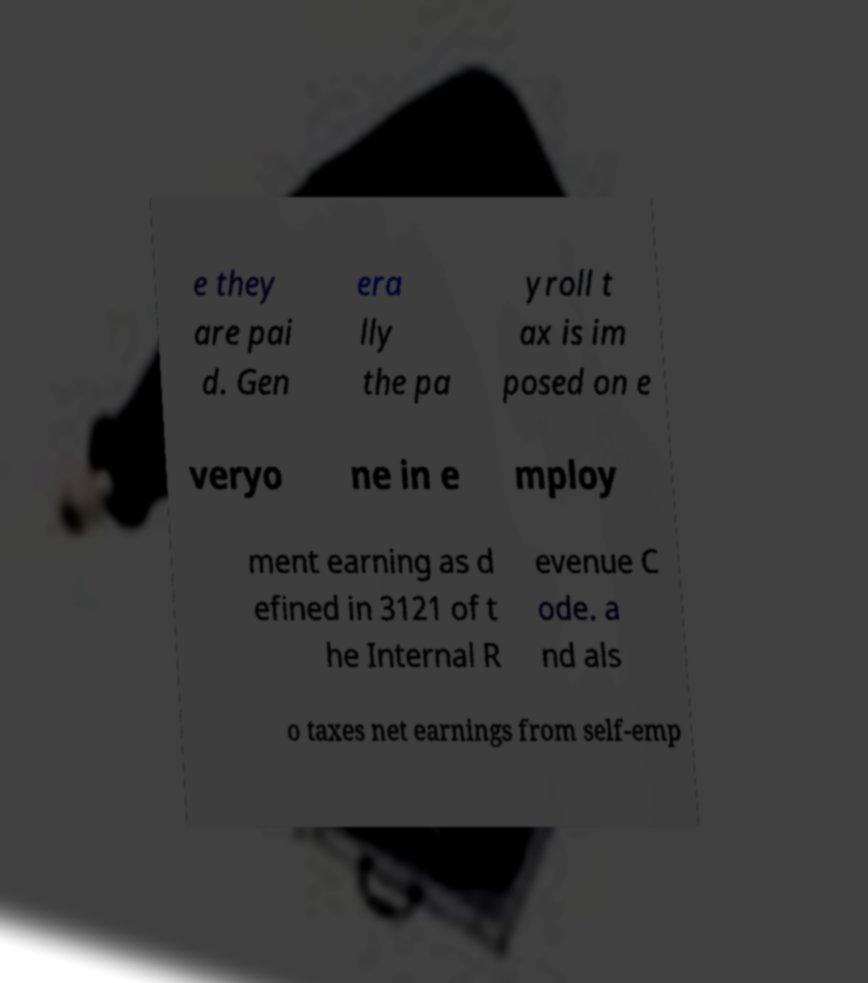Please identify and transcribe the text found in this image. e they are pai d. Gen era lly the pa yroll t ax is im posed on e veryo ne in e mploy ment earning as d efined in 3121 of t he Internal R evenue C ode. a nd als o taxes net earnings from self-emp 